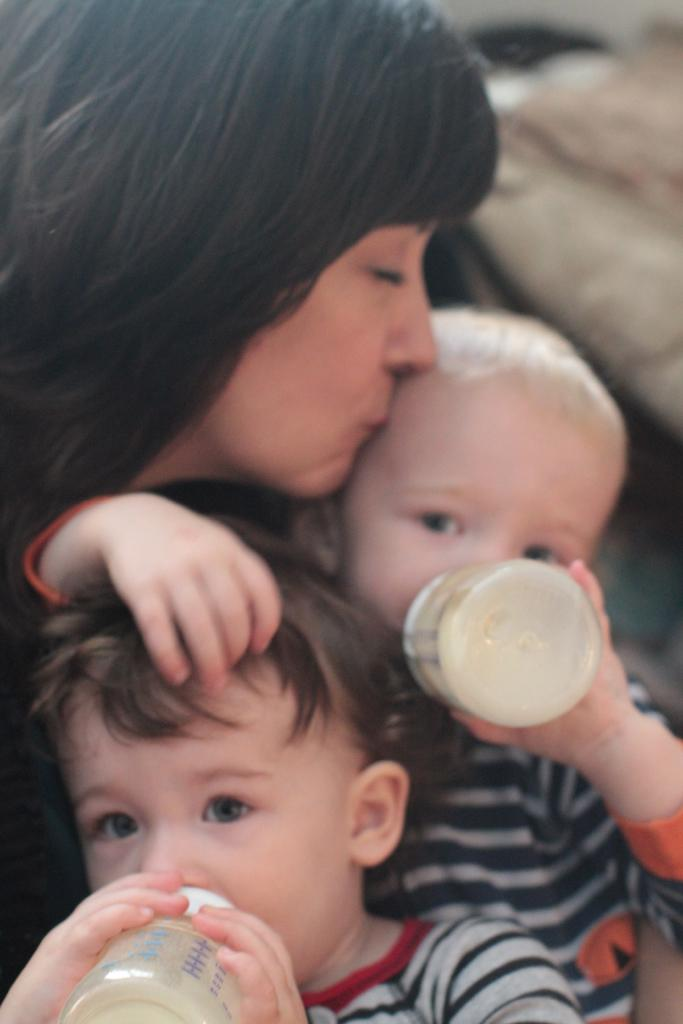Who is the main subject in the image? There is a woman in the image. What is the woman doing in the image? The woman is kissing a child. What is the child doing while being kissed? The child is drinking milk from a feeding bottle. Are there any other children in the image? Yes, there is another child in the image. What is the second child doing? The second child is also drinking. What type of action is taking place in space in the image? There is no reference to space or any actions taking place in space in the image. 